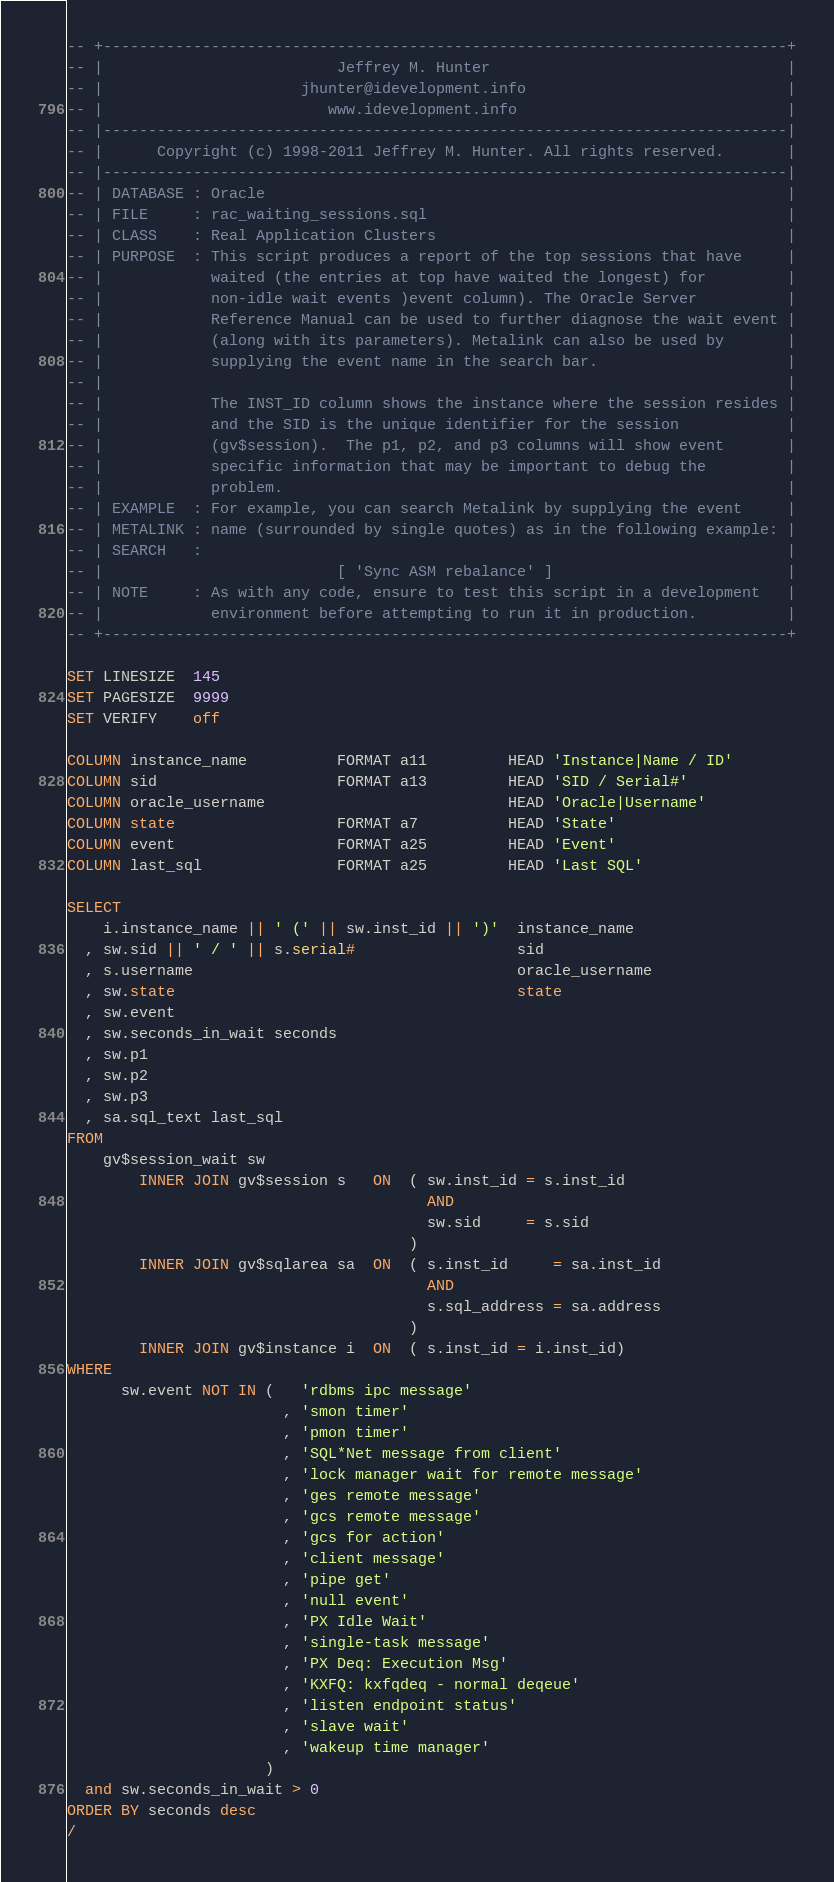Convert code to text. <code><loc_0><loc_0><loc_500><loc_500><_SQL_>-- +----------------------------------------------------------------------------+
-- |                          Jeffrey M. Hunter                                 |
-- |                      jhunter@idevelopment.info                             |
-- |                         www.idevelopment.info                              |
-- |----------------------------------------------------------------------------|
-- |      Copyright (c) 1998-2011 Jeffrey M. Hunter. All rights reserved.       |
-- |----------------------------------------------------------------------------|
-- | DATABASE : Oracle                                                          |
-- | FILE     : rac_waiting_sessions.sql                                        |
-- | CLASS    : Real Application Clusters                                       |
-- | PURPOSE  : This script produces a report of the top sessions that have     |
-- |            waited (the entries at top have waited the longest) for         |
-- |            non-idle wait events )event column). The Oracle Server          |
-- |            Reference Manual can be used to further diagnose the wait event |
-- |            (along with its parameters). Metalink can also be used by       |
-- |            supplying the event name in the search bar.                     |
-- |                                                                            |
-- |            The INST_ID column shows the instance where the session resides |
-- |            and the SID is the unique identifier for the session            |
-- |            (gv$session).  The p1, p2, and p3 columns will show event       |
-- |            specific information that may be important to debug the         |
-- |            problem.                                                        |
-- | EXAMPLE  : For example, you can search Metalink by supplying the event     |
-- | METALINK : name (surrounded by single quotes) as in the following example: |
-- | SEARCH   :                                                                 |
-- |                          [ 'Sync ASM rebalance' ]                          |
-- | NOTE     : As with any code, ensure to test this script in a development   |
-- |            environment before attempting to run it in production.          |
-- +----------------------------------------------------------------------------+

SET LINESIZE  145
SET PAGESIZE  9999
SET VERIFY    off

COLUMN instance_name          FORMAT a11         HEAD 'Instance|Name / ID'
COLUMN sid                    FORMAT a13         HEAD 'SID / Serial#'
COLUMN oracle_username                           HEAD 'Oracle|Username'
COLUMN state                  FORMAT a7          HEAD 'State'
COLUMN event                  FORMAT a25         HEAD 'Event'
COLUMN last_sql               FORMAT a25         HEAD 'Last SQL'

SELECT
    i.instance_name || ' (' || sw.inst_id || ')'  instance_name
  , sw.sid || ' / ' || s.serial#                  sid
  , s.username                                    oracle_username
  , sw.state                                      state
  , sw.event
  , sw.seconds_in_wait seconds
  , sw.p1
  , sw.p2
  , sw.p3
  , sa.sql_text last_sql
FROM
    gv$session_wait sw
        INNER JOIN gv$session s   ON  ( sw.inst_id = s.inst_id
                                        AND
                                        sw.sid     = s.sid
                                      )
        INNER JOIN gv$sqlarea sa  ON  ( s.inst_id     = sa.inst_id
                                        AND
                                        s.sql_address = sa.address
                                      )
        INNER JOIN gv$instance i  ON  ( s.inst_id = i.inst_id)
WHERE
      sw.event NOT IN (   'rdbms ipc message'
                        , 'smon timer'
                        , 'pmon timer'
                        , 'SQL*Net message from client'
                        , 'lock manager wait for remote message'
                        , 'ges remote message'
                        , 'gcs remote message'
                        , 'gcs for action'
                        , 'client message'
                        , 'pipe get'
                        , 'null event'
                        , 'PX Idle Wait'
                        , 'single-task message'
                        , 'PX Deq: Execution Msg'
                        , 'KXFQ: kxfqdeq - normal deqeue'
                        , 'listen endpoint status'
                        , 'slave wait'
                        , 'wakeup time manager'
                      )
  and sw.seconds_in_wait > 0 
ORDER BY seconds desc
/
</code> 